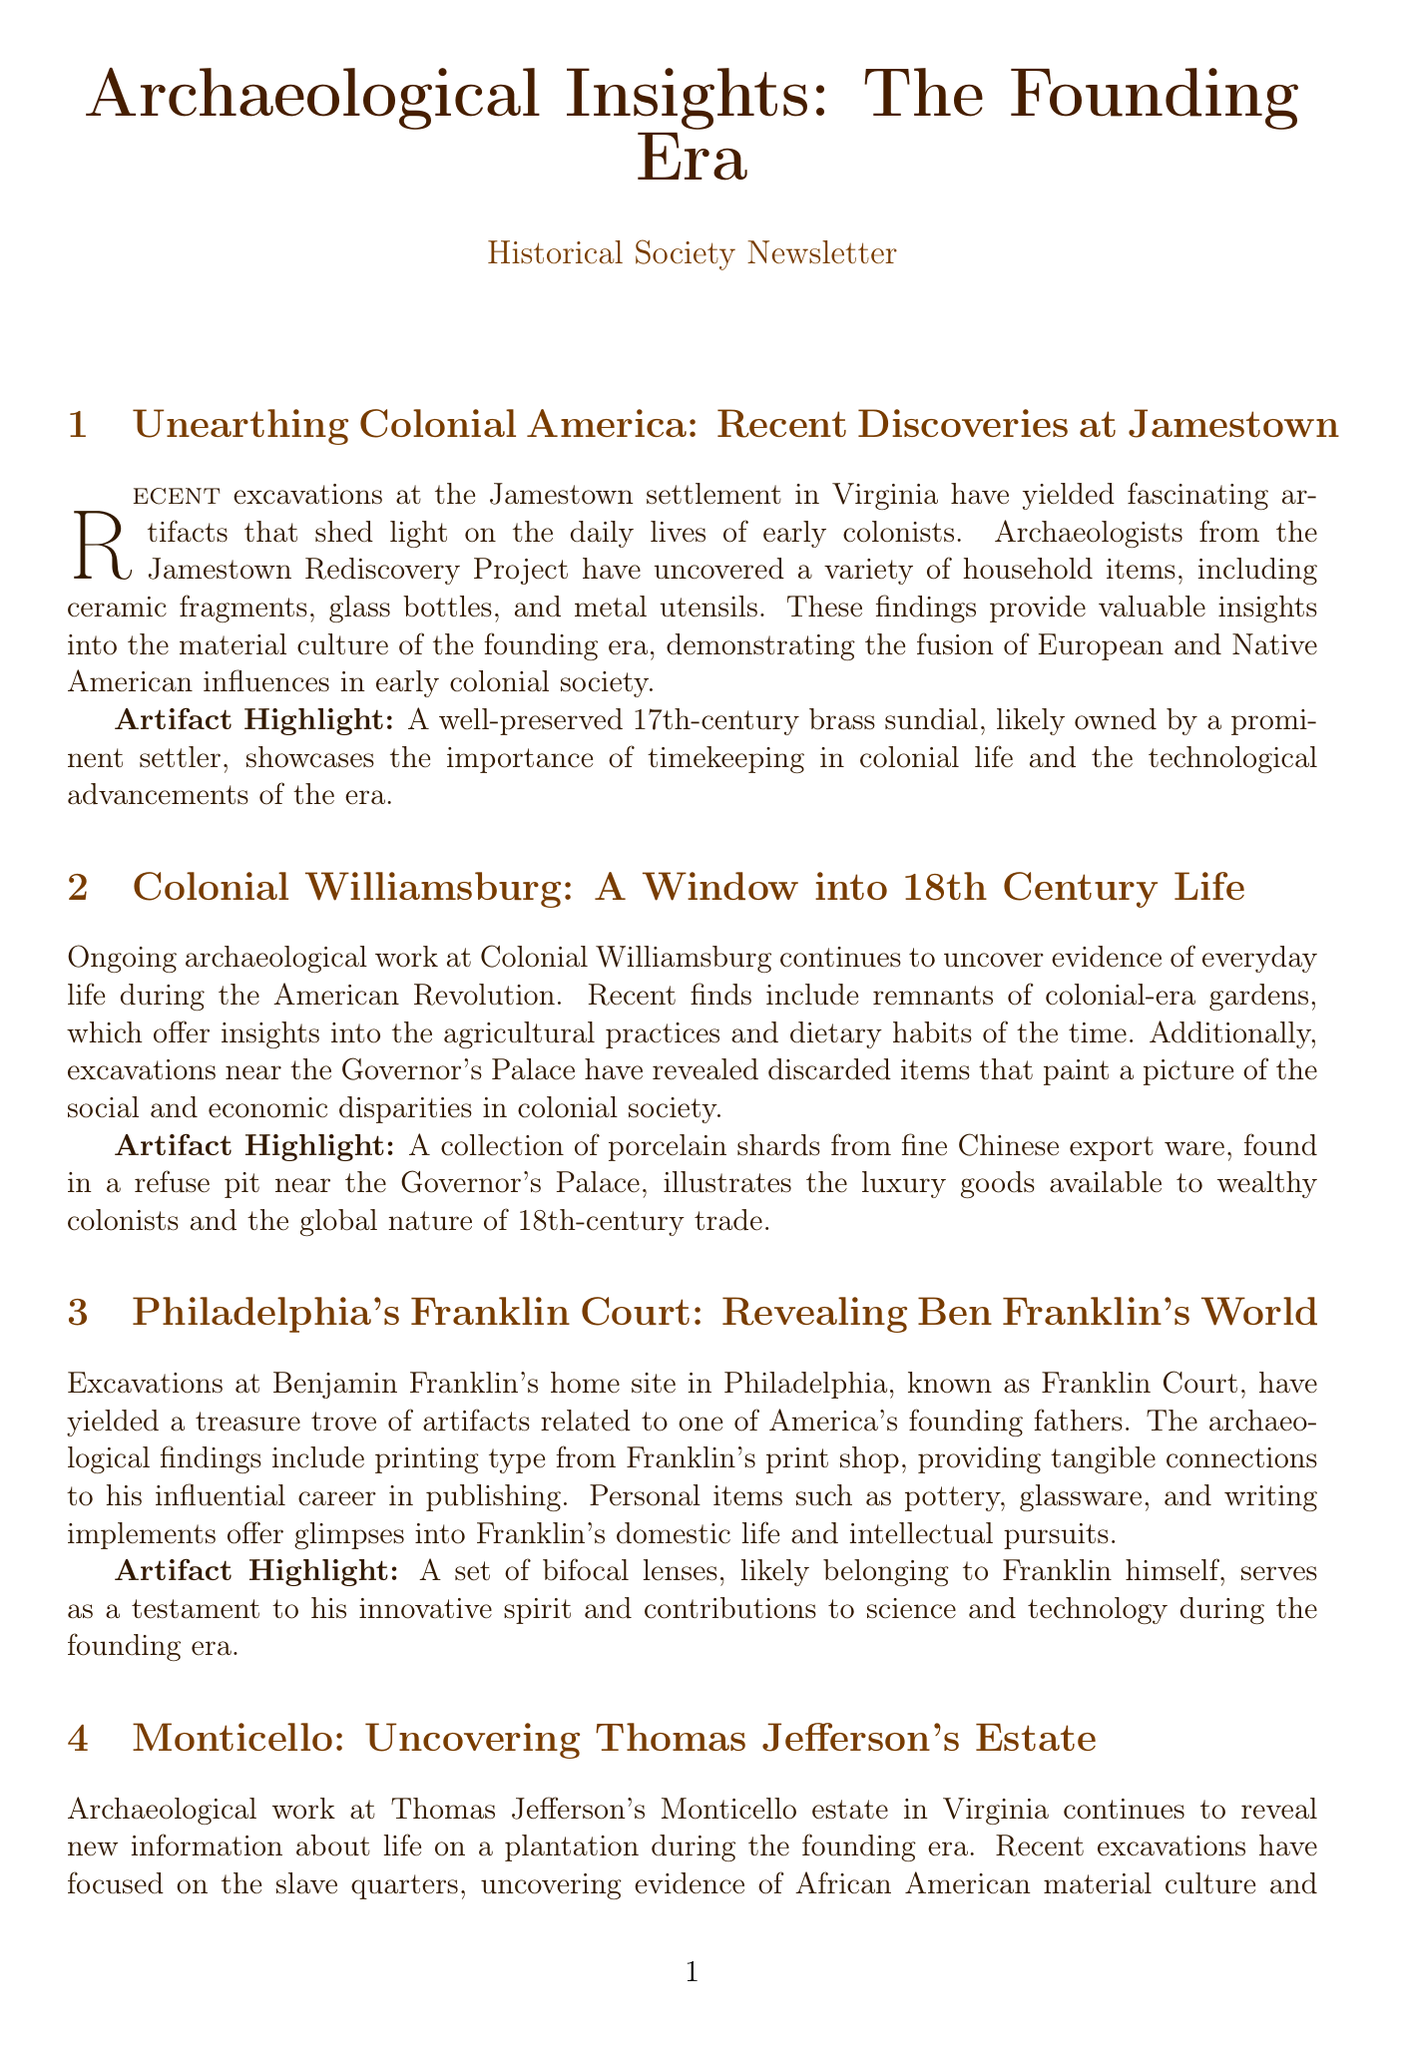what is the title of the newsletter? The title of the newsletter is prominently displayed at the beginning of the document and reflects its main theme.
Answer: Archaeological Insights: The Founding Era who conducted the excavations at Jamestown? The newsletter mentions archaeologists from a specific project that are responsible for the discoveries at Jamestown.
Answer: Jamestown Rediscovery Project what type of artifact was highlighted from Colonial Williamsburg? The highlighting of an artifact in each section shows the most significant finding related to daily life during that period.
Answer: porcelain shards which foundational figure's home site was excavated in Philadelphia? The document explicitly states the name of the historical figure associated with Franklin Court and his contributions.
Answer: Benjamin Franklin what does the British officer's gorget signify? The document explains the significance of particular artifacts found at Fort Ticonderoga, indicating their relevance in military culture.
Answer: military rank how many sections are in the newsletter? By counting the sections in the document, one can determine the total number of featured archaeological findings.
Answer: five what item was found near the slave quarters at Monticello? The specific item mentioned in relation to African American culture at Monticello indicates its significance in the findings.
Answer: cowrie shells why are the porcelain shards significant? The significance of particular items found reflects societal aspects during the colonial period that are explored in the newsletter.
Answer: luxury goods which Virginia estate is associated with Thomas Jefferson? The newsletter provides specific information about a well-known historical figure and their residence.
Answer: Monticello 